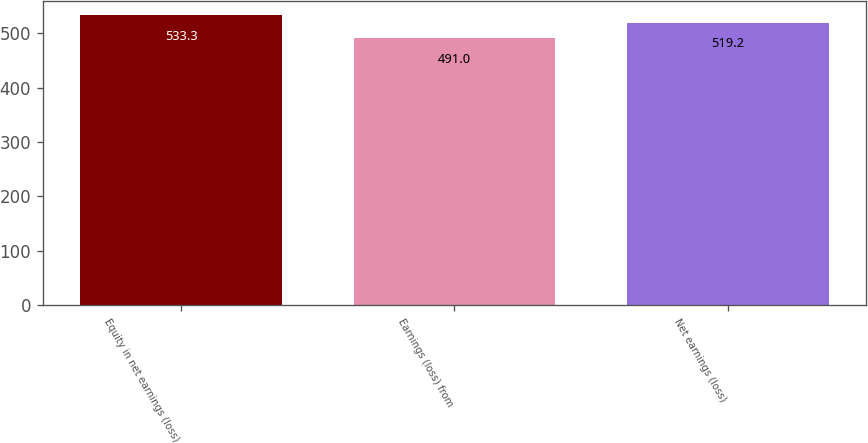Convert chart to OTSL. <chart><loc_0><loc_0><loc_500><loc_500><bar_chart><fcel>Equity in net earnings (loss)<fcel>Earnings (loss) from<fcel>Net earnings (loss)<nl><fcel>533.3<fcel>491<fcel>519.2<nl></chart> 